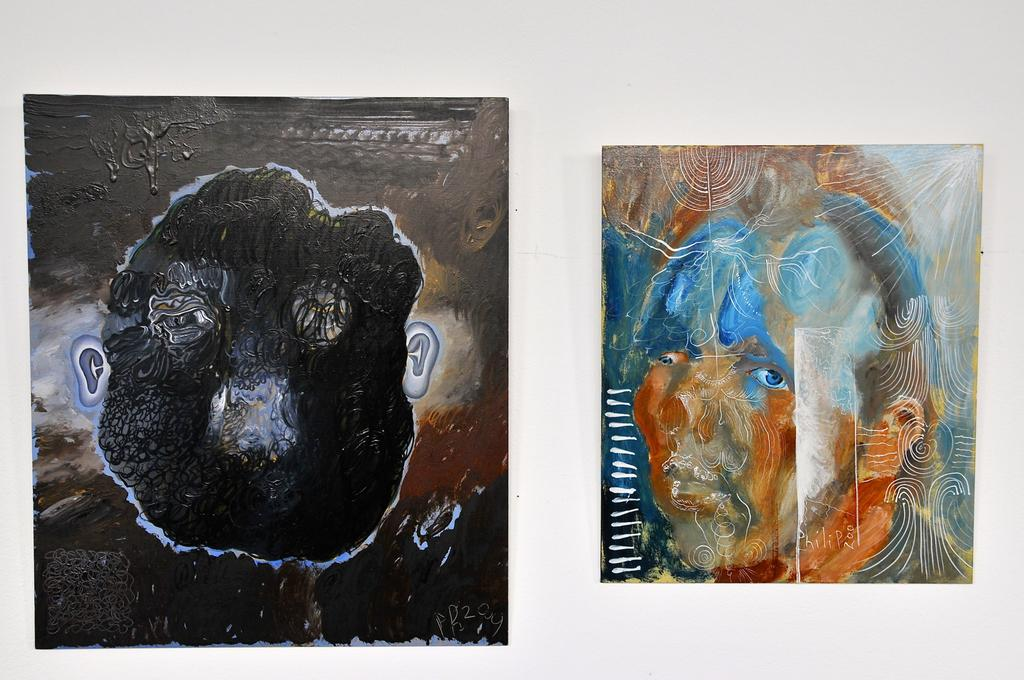How many paintings are visible in the image? There are two paintings in the image. Can you describe the colors and subjects of the paintings? One painting is brown in color and has a human face, while the other painting is blue and orange in color and also has a human face. What type of powder is being used to create the texture in the blue and orange painting? There is no mention of powder or any texture-creating materials in the image; the paintings are described solely by their colors and subjects. 